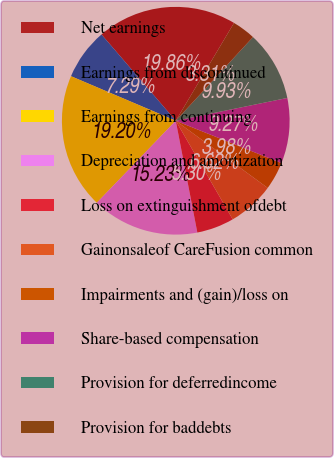Convert chart to OTSL. <chart><loc_0><loc_0><loc_500><loc_500><pie_chart><fcel>Net earnings<fcel>Earnings from discontinued<fcel>Earnings from continuing<fcel>Depreciation and amortization<fcel>Loss on extinguishment ofdebt<fcel>Gainonsaleof CareFusion common<fcel>Impairments and (gain)/loss on<fcel>Share-based compensation<fcel>Provision for deferredincome<fcel>Provision for baddebts<nl><fcel>19.86%<fcel>7.29%<fcel>19.2%<fcel>15.23%<fcel>5.3%<fcel>6.62%<fcel>3.98%<fcel>9.27%<fcel>9.93%<fcel>3.31%<nl></chart> 